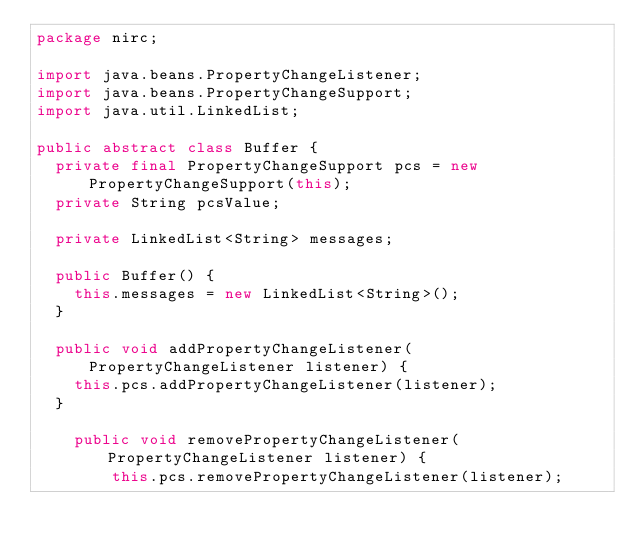<code> <loc_0><loc_0><loc_500><loc_500><_Java_>package nirc;

import java.beans.PropertyChangeListener;
import java.beans.PropertyChangeSupport;
import java.util.LinkedList;

public abstract class Buffer {
	private final PropertyChangeSupport pcs = new PropertyChangeSupport(this);
	private String pcsValue;
	
	private LinkedList<String> messages;
	
	public Buffer() {
		this.messages = new LinkedList<String>();
	}
	
	public void addPropertyChangeListener(PropertyChangeListener listener) {
		this.pcs.addPropertyChangeListener(listener);
	}

    public void removePropertyChangeListener(PropertyChangeListener listener) {
        this.pcs.removePropertyChangeListener(listener);</code> 